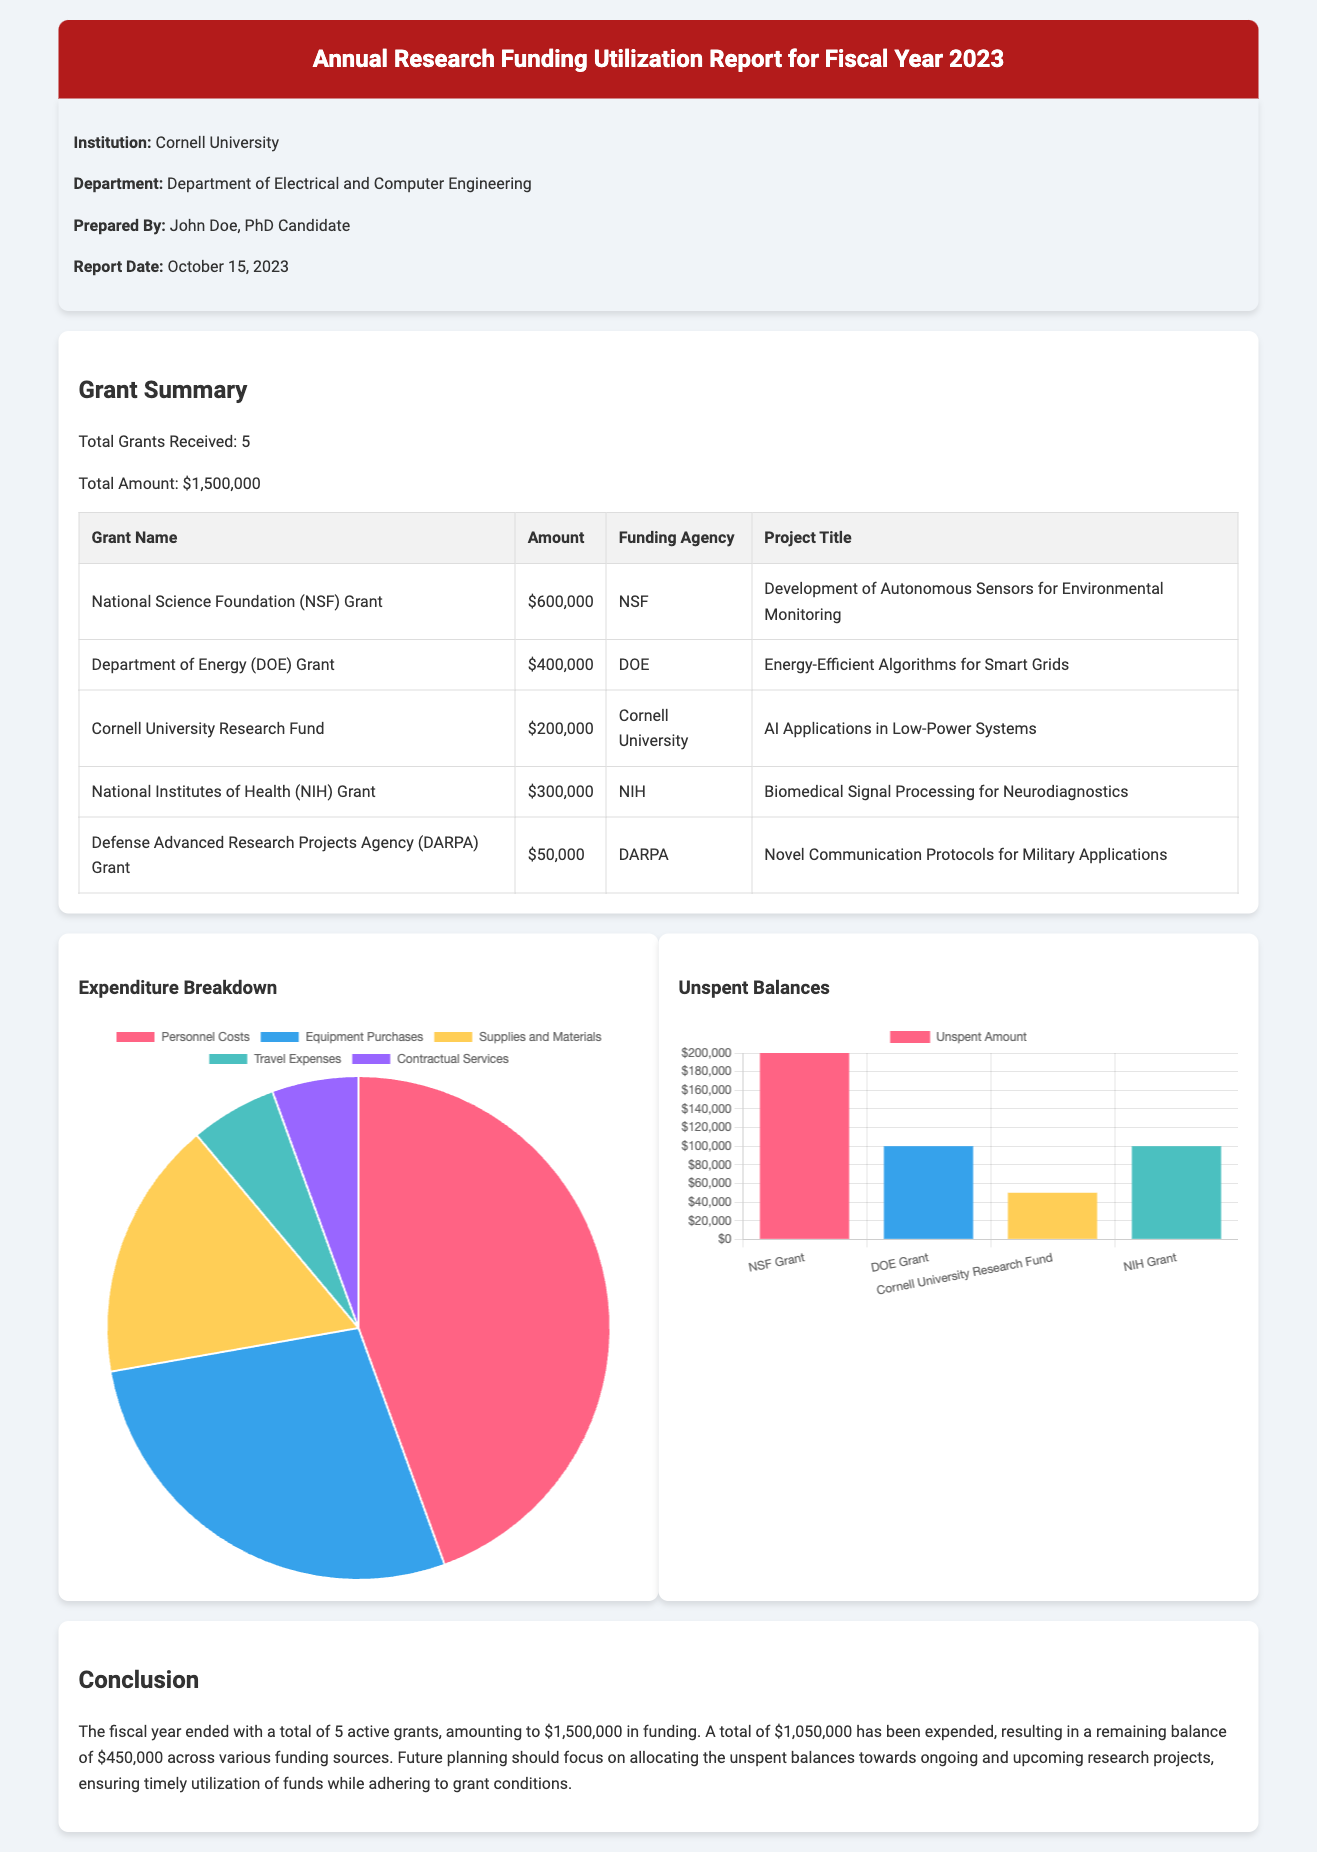What is the total number of grants received? The total number of grants received is explicitly stated in the report summary.
Answer: 5 What is the total amount of funding received? The total amount of funding is mentioned in the grant summary of the report.
Answer: $1,500,000 What is the title of the project funded by the Department of Energy grant? The specific project title associated with the Department of Energy grant can be found in the grant table.
Answer: Energy-Efficient Algorithms for Smart Grids What is the unspent amount for the Cornell University Research Fund? The unspent balance for each grant is detailed within the unspent balances chart.
Answer: $50,000 How much has been expended in total? The total expenditure amount is provided in the report's conclusion.
Answer: $1,050,000 Which agency funded the grant for Biomedical Signal Processing? The funding agency for this grant is listed in the grant table associated with the project.
Answer: NIH What percentage of the total amount remains unspent? The unspent balance is calculated as the difference between total funding and total expenditure, which relates to the financial situation detailed in the report.
Answer: 30% What type of report is this document classified as? The classification of the document can be inferred from the title and content.
Answer: Financial Report What are the two charts displayed in the report? The report contains two charts, each focusing on different aspects of funding utilization.
Answer: Expenditure Breakdown and Unspent Balances 